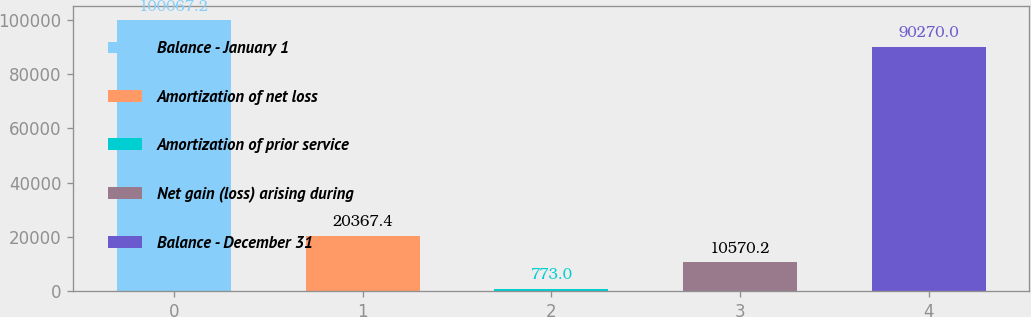Convert chart to OTSL. <chart><loc_0><loc_0><loc_500><loc_500><bar_chart><fcel>Balance - January 1<fcel>Amortization of net loss<fcel>Amortization of prior service<fcel>Net gain (loss) arising during<fcel>Balance - December 31<nl><fcel>100067<fcel>20367.4<fcel>773<fcel>10570.2<fcel>90270<nl></chart> 